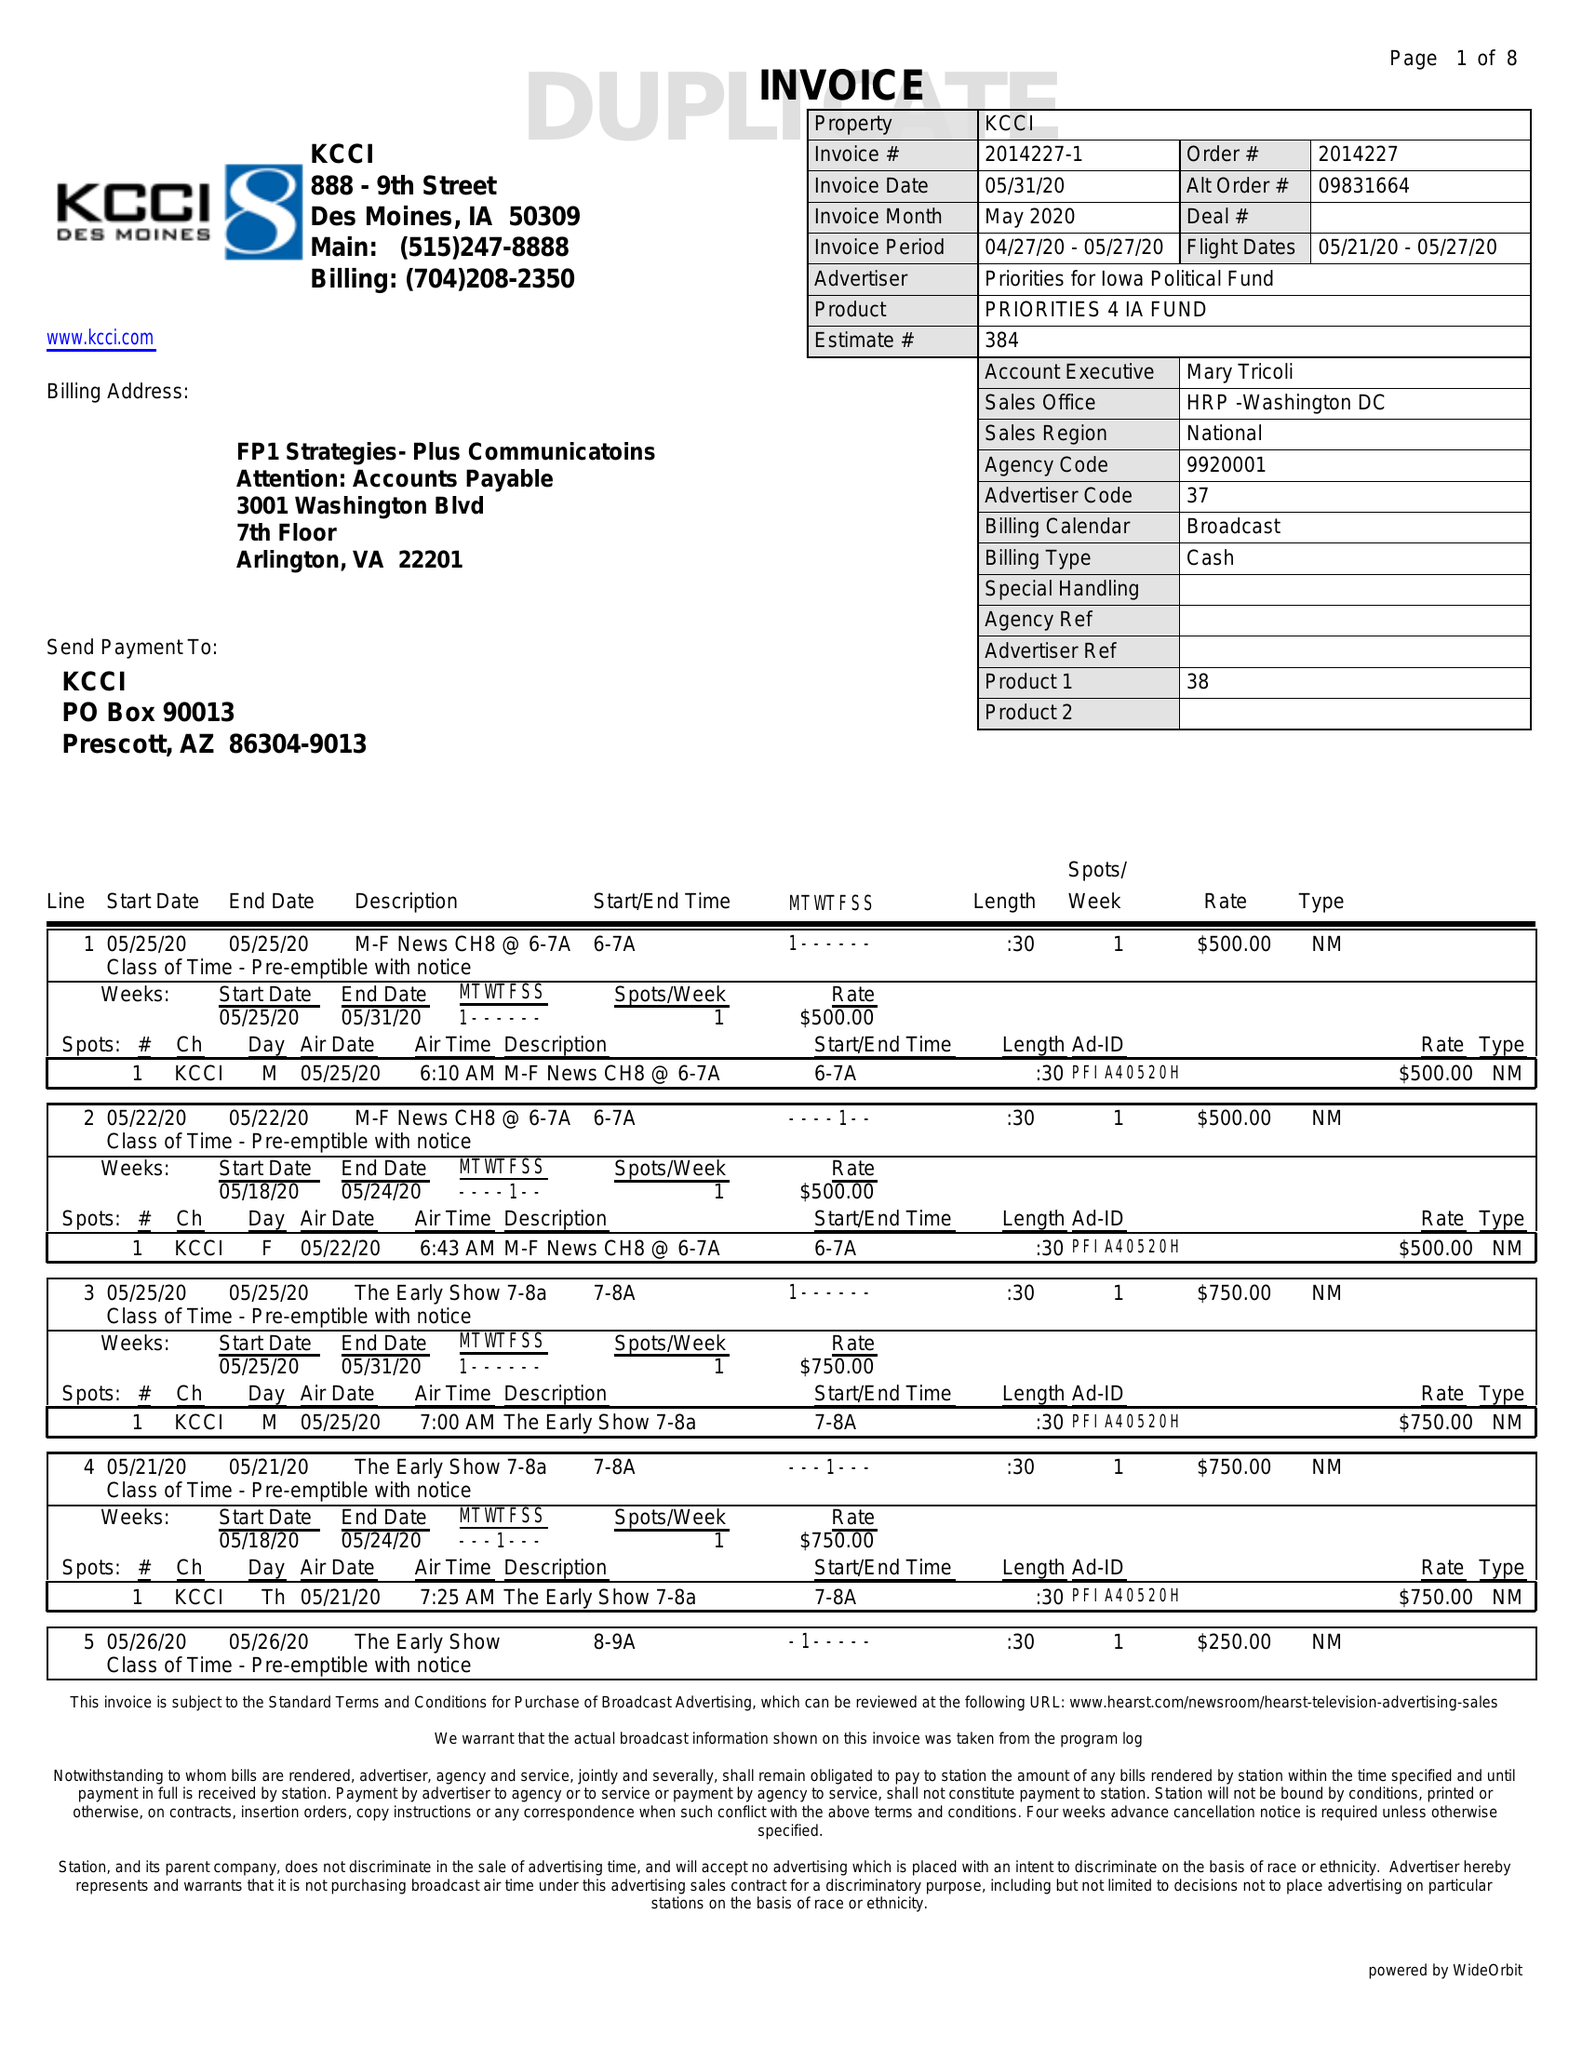What is the value for the gross_amount?
Answer the question using a single word or phrase. 21300.00 